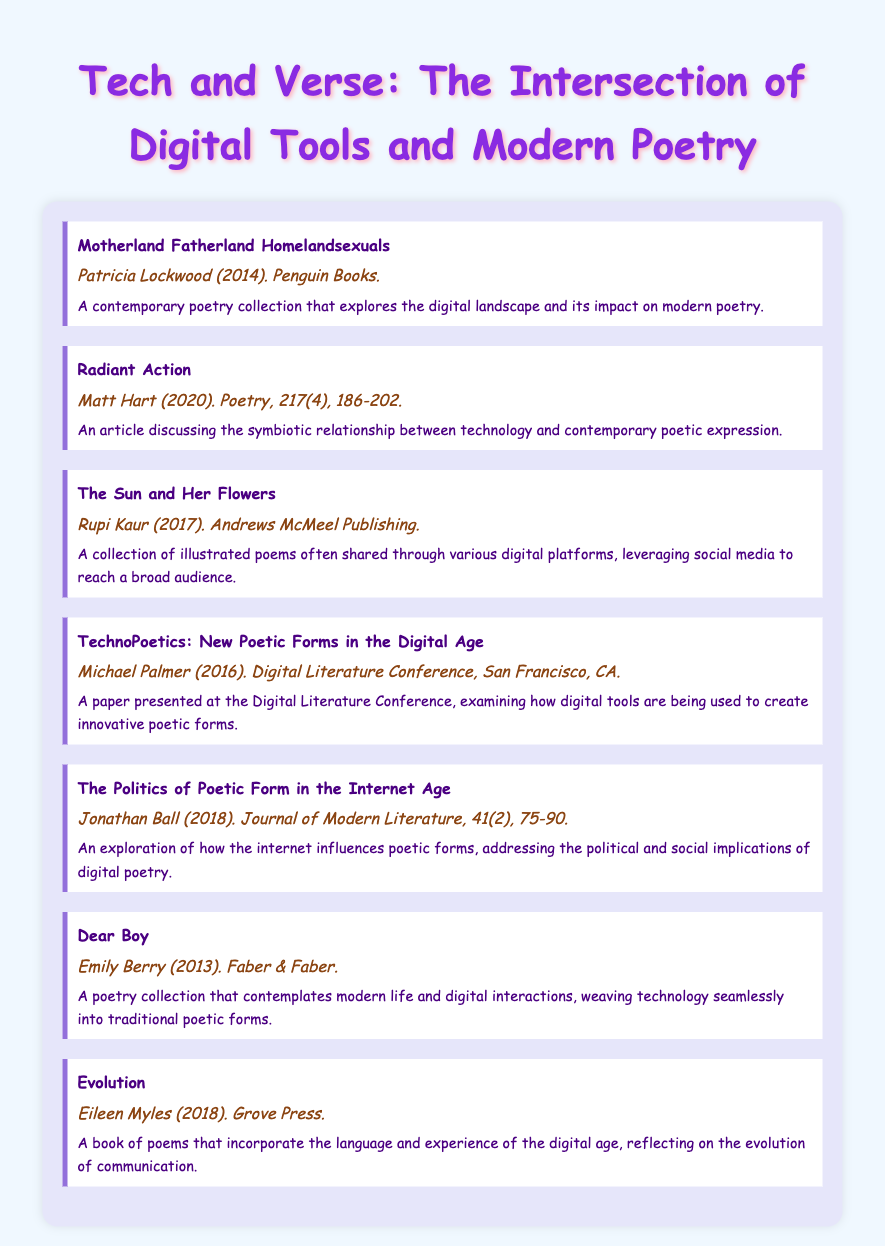What is the title of Patricia Lockwood's work? The title is mentioned in the first entry of the bibliography, which lists "Motherland Fatherland Homelandsexuals."
Answer: Motherland Fatherland Homelandsexuals Who published "The Sun and Her Flowers"? The publisher of this collection is provided in the third entry, which states Andrews McMeel Publishing.
Answer: Andrews McMeel Publishing In what year was "Radiant Action" published? The publication year is listed in the second entry, detailing that it was published in 2020.
Answer: 2020 What is the primary theme of Michael Palmer's paper? The theme is explained in the entry that mentions it examines digital tools and innovative poetic forms.
Answer: Innovative poetic forms Which poet's collection contemplates modern life? The entry for "Dear Boy" mentions it reflects on modern life and digital interactions.
Answer: Emily Berry What journal features Jonathan Ball's work? The journal title is given in the fifth entry as the Journal of Modern Literature.
Answer: Journal of Modern Literature How many entries are listed in the bibliography? By counting the number of distinct works, the total is provided in the document.
Answer: Seven What type of document is this? It is explicitly identified at the beginning of the document as a bibliography.
Answer: Bibliography 